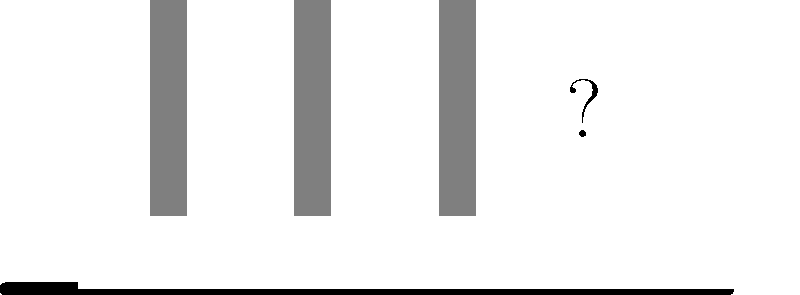This image represents a famous album cover with a key element removed. Which iconic Beatles album is this, and what's missing from the image? To identify this album cover and the missing element, let's break it down step-by-step:

1. The image shows a simplified representation of a road with a zebra crossing (crosswalk).
2. There are three gray silhouettes walking across the road.
3. These elements are iconic features of The Beatles' "Abbey Road" album cover.
4. The album cover typically features four figures walking across the zebra crossing, representing the four members of The Beatles.
5. In this simplified version, we can see only three figures, with a question mark where the fourth should be.
6. The missing fourth figure would represent Paul McCartney, who was walking slightly out of step with the others and barefoot in the original photograph.

Given the persona of a pop culture enthusiast, recognizing this iconic album cover should be relatively straightforward. The missing fourth figure is the key element that has been removed, making it the answer to the second part of the question.
Answer: Abbey Road; fourth Beatles member (Paul McCartney) 